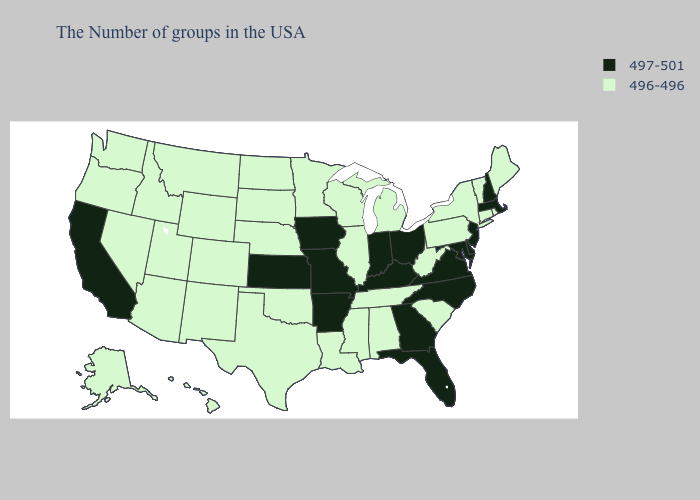What is the value of Louisiana?
Write a very short answer. 496-496. Name the states that have a value in the range 496-496?
Answer briefly. Maine, Rhode Island, Vermont, Connecticut, New York, Pennsylvania, South Carolina, West Virginia, Michigan, Alabama, Tennessee, Wisconsin, Illinois, Mississippi, Louisiana, Minnesota, Nebraska, Oklahoma, Texas, South Dakota, North Dakota, Wyoming, Colorado, New Mexico, Utah, Montana, Arizona, Idaho, Nevada, Washington, Oregon, Alaska, Hawaii. What is the lowest value in the MidWest?
Short answer required. 496-496. Which states have the lowest value in the USA?
Quick response, please. Maine, Rhode Island, Vermont, Connecticut, New York, Pennsylvania, South Carolina, West Virginia, Michigan, Alabama, Tennessee, Wisconsin, Illinois, Mississippi, Louisiana, Minnesota, Nebraska, Oklahoma, Texas, South Dakota, North Dakota, Wyoming, Colorado, New Mexico, Utah, Montana, Arizona, Idaho, Nevada, Washington, Oregon, Alaska, Hawaii. Name the states that have a value in the range 496-496?
Answer briefly. Maine, Rhode Island, Vermont, Connecticut, New York, Pennsylvania, South Carolina, West Virginia, Michigan, Alabama, Tennessee, Wisconsin, Illinois, Mississippi, Louisiana, Minnesota, Nebraska, Oklahoma, Texas, South Dakota, North Dakota, Wyoming, Colorado, New Mexico, Utah, Montana, Arizona, Idaho, Nevada, Washington, Oregon, Alaska, Hawaii. What is the lowest value in the West?
Keep it brief. 496-496. Name the states that have a value in the range 497-501?
Be succinct. Massachusetts, New Hampshire, New Jersey, Delaware, Maryland, Virginia, North Carolina, Ohio, Florida, Georgia, Kentucky, Indiana, Missouri, Arkansas, Iowa, Kansas, California. Name the states that have a value in the range 496-496?
Answer briefly. Maine, Rhode Island, Vermont, Connecticut, New York, Pennsylvania, South Carolina, West Virginia, Michigan, Alabama, Tennessee, Wisconsin, Illinois, Mississippi, Louisiana, Minnesota, Nebraska, Oklahoma, Texas, South Dakota, North Dakota, Wyoming, Colorado, New Mexico, Utah, Montana, Arizona, Idaho, Nevada, Washington, Oregon, Alaska, Hawaii. Name the states that have a value in the range 496-496?
Quick response, please. Maine, Rhode Island, Vermont, Connecticut, New York, Pennsylvania, South Carolina, West Virginia, Michigan, Alabama, Tennessee, Wisconsin, Illinois, Mississippi, Louisiana, Minnesota, Nebraska, Oklahoma, Texas, South Dakota, North Dakota, Wyoming, Colorado, New Mexico, Utah, Montana, Arizona, Idaho, Nevada, Washington, Oregon, Alaska, Hawaii. Name the states that have a value in the range 497-501?
Short answer required. Massachusetts, New Hampshire, New Jersey, Delaware, Maryland, Virginia, North Carolina, Ohio, Florida, Georgia, Kentucky, Indiana, Missouri, Arkansas, Iowa, Kansas, California. Does Georgia have the highest value in the USA?
Quick response, please. Yes. Does Indiana have the highest value in the USA?
Quick response, please. Yes. What is the value of Oklahoma?
Give a very brief answer. 496-496. Does Louisiana have the lowest value in the South?
Answer briefly. Yes. What is the value of Nebraska?
Quick response, please. 496-496. 